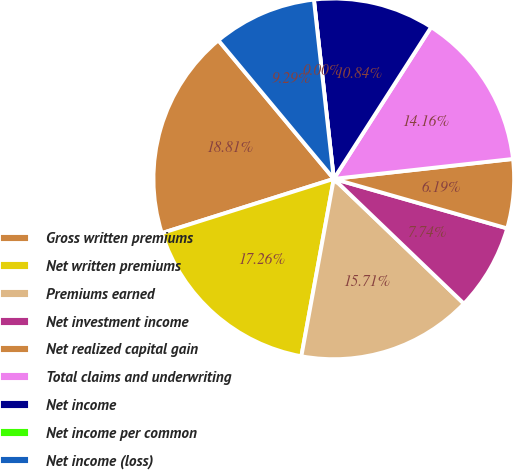Convert chart. <chart><loc_0><loc_0><loc_500><loc_500><pie_chart><fcel>Gross written premiums<fcel>Net written premiums<fcel>Premiums earned<fcel>Net investment income<fcel>Net realized capital gain<fcel>Total claims and underwriting<fcel>Net income<fcel>Net income per common<fcel>Net income (loss)<nl><fcel>18.81%<fcel>17.26%<fcel>15.71%<fcel>7.74%<fcel>6.19%<fcel>14.16%<fcel>10.84%<fcel>0.0%<fcel>9.29%<nl></chart> 